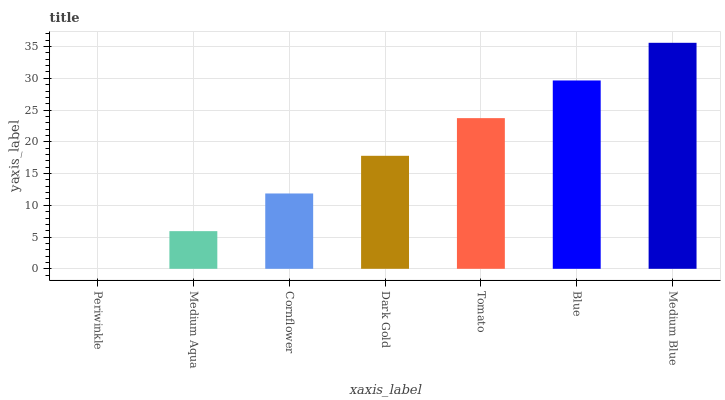Is Periwinkle the minimum?
Answer yes or no. Yes. Is Medium Blue the maximum?
Answer yes or no. Yes. Is Medium Aqua the minimum?
Answer yes or no. No. Is Medium Aqua the maximum?
Answer yes or no. No. Is Medium Aqua greater than Periwinkle?
Answer yes or no. Yes. Is Periwinkle less than Medium Aqua?
Answer yes or no. Yes. Is Periwinkle greater than Medium Aqua?
Answer yes or no. No. Is Medium Aqua less than Periwinkle?
Answer yes or no. No. Is Dark Gold the high median?
Answer yes or no. Yes. Is Dark Gold the low median?
Answer yes or no. Yes. Is Tomato the high median?
Answer yes or no. No. Is Blue the low median?
Answer yes or no. No. 